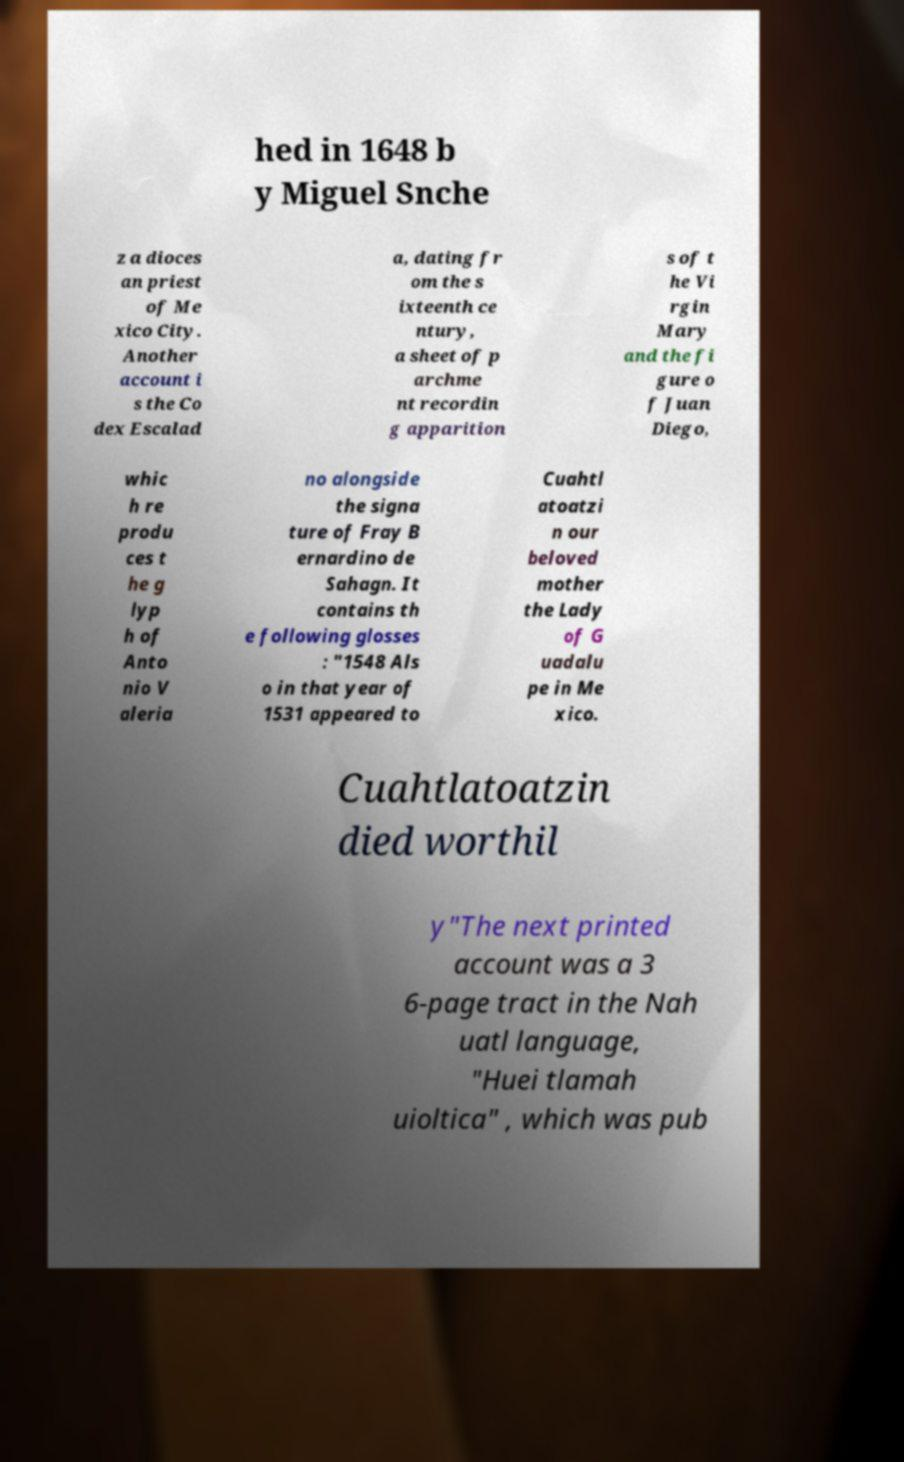Can you read and provide the text displayed in the image?This photo seems to have some interesting text. Can you extract and type it out for me? hed in 1648 b y Miguel Snche z a dioces an priest of Me xico City. Another account i s the Co dex Escalad a, dating fr om the s ixteenth ce ntury, a sheet of p archme nt recordin g apparition s of t he Vi rgin Mary and the fi gure o f Juan Diego, whic h re produ ces t he g lyp h of Anto nio V aleria no alongside the signa ture of Fray B ernardino de Sahagn. It contains th e following glosses : "1548 Als o in that year of 1531 appeared to Cuahtl atoatzi n our beloved mother the Lady of G uadalu pe in Me xico. Cuahtlatoatzin died worthil y"The next printed account was a 3 6-page tract in the Nah uatl language, "Huei tlamah uioltica" , which was pub 